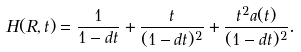<formula> <loc_0><loc_0><loc_500><loc_500>H ( R , t ) = \frac { 1 } { 1 - d t } + \frac { t } { ( 1 - d t ) ^ { 2 } } + \frac { t ^ { 2 } a ( t ) } { ( 1 - d t ) ^ { 2 } } .</formula> 